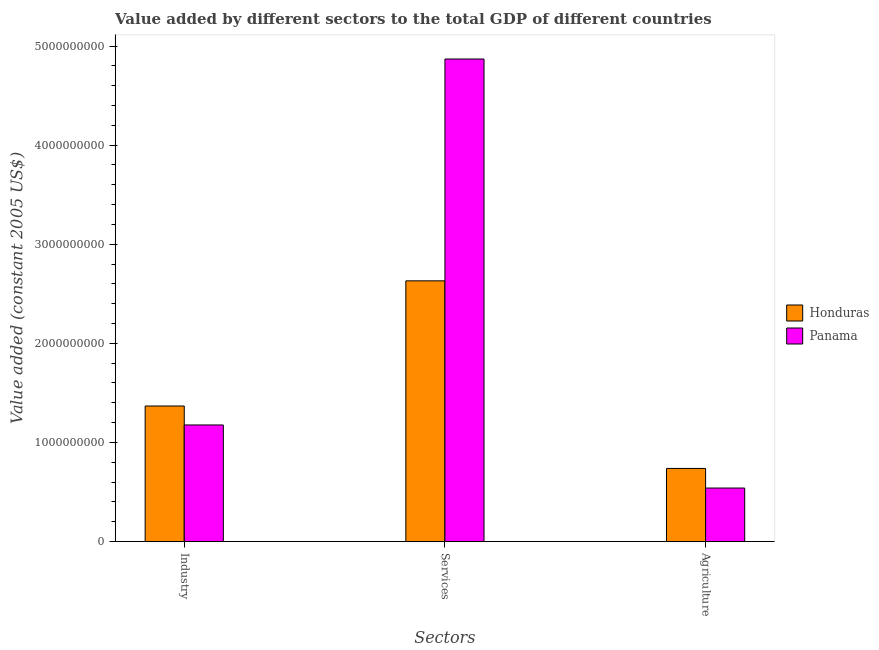How many different coloured bars are there?
Your answer should be compact. 2. How many groups of bars are there?
Your response must be concise. 3. Are the number of bars on each tick of the X-axis equal?
Your response must be concise. Yes. How many bars are there on the 3rd tick from the right?
Keep it short and to the point. 2. What is the label of the 1st group of bars from the left?
Provide a succinct answer. Industry. What is the value added by services in Panama?
Offer a very short reply. 4.87e+09. Across all countries, what is the maximum value added by industrial sector?
Provide a short and direct response. 1.37e+09. Across all countries, what is the minimum value added by agricultural sector?
Your answer should be very brief. 5.40e+08. In which country was the value added by agricultural sector maximum?
Offer a very short reply. Honduras. In which country was the value added by services minimum?
Provide a short and direct response. Honduras. What is the total value added by agricultural sector in the graph?
Ensure brevity in your answer.  1.28e+09. What is the difference between the value added by industrial sector in Honduras and that in Panama?
Your response must be concise. 1.91e+08. What is the difference between the value added by services in Honduras and the value added by agricultural sector in Panama?
Ensure brevity in your answer.  2.09e+09. What is the average value added by services per country?
Provide a short and direct response. 3.75e+09. What is the difference between the value added by services and value added by industrial sector in Honduras?
Offer a terse response. 1.26e+09. In how many countries, is the value added by agricultural sector greater than 200000000 US$?
Ensure brevity in your answer.  2. What is the ratio of the value added by industrial sector in Panama to that in Honduras?
Keep it short and to the point. 0.86. Is the value added by industrial sector in Honduras less than that in Panama?
Keep it short and to the point. No. Is the difference between the value added by industrial sector in Panama and Honduras greater than the difference between the value added by agricultural sector in Panama and Honduras?
Your response must be concise. Yes. What is the difference between the highest and the second highest value added by services?
Offer a terse response. 2.24e+09. What is the difference between the highest and the lowest value added by services?
Ensure brevity in your answer.  2.24e+09. Is the sum of the value added by industrial sector in Honduras and Panama greater than the maximum value added by agricultural sector across all countries?
Provide a short and direct response. Yes. What does the 2nd bar from the left in Agriculture represents?
Your response must be concise. Panama. What does the 2nd bar from the right in Services represents?
Provide a succinct answer. Honduras. How many bars are there?
Ensure brevity in your answer.  6. Are all the bars in the graph horizontal?
Your answer should be compact. No. How many countries are there in the graph?
Your response must be concise. 2. What is the difference between two consecutive major ticks on the Y-axis?
Your answer should be very brief. 1.00e+09. How are the legend labels stacked?
Make the answer very short. Vertical. What is the title of the graph?
Your answer should be compact. Value added by different sectors to the total GDP of different countries. Does "Morocco" appear as one of the legend labels in the graph?
Provide a succinct answer. No. What is the label or title of the X-axis?
Offer a terse response. Sectors. What is the label or title of the Y-axis?
Provide a succinct answer. Value added (constant 2005 US$). What is the Value added (constant 2005 US$) of Honduras in Industry?
Offer a terse response. 1.37e+09. What is the Value added (constant 2005 US$) in Panama in Industry?
Your answer should be very brief. 1.18e+09. What is the Value added (constant 2005 US$) in Honduras in Services?
Keep it short and to the point. 2.63e+09. What is the Value added (constant 2005 US$) in Panama in Services?
Provide a short and direct response. 4.87e+09. What is the Value added (constant 2005 US$) in Honduras in Agriculture?
Your answer should be very brief. 7.38e+08. What is the Value added (constant 2005 US$) of Panama in Agriculture?
Make the answer very short. 5.40e+08. Across all Sectors, what is the maximum Value added (constant 2005 US$) in Honduras?
Keep it short and to the point. 2.63e+09. Across all Sectors, what is the maximum Value added (constant 2005 US$) of Panama?
Provide a short and direct response. 4.87e+09. Across all Sectors, what is the minimum Value added (constant 2005 US$) of Honduras?
Offer a terse response. 7.38e+08. Across all Sectors, what is the minimum Value added (constant 2005 US$) in Panama?
Provide a succinct answer. 5.40e+08. What is the total Value added (constant 2005 US$) of Honduras in the graph?
Offer a very short reply. 4.74e+09. What is the total Value added (constant 2005 US$) of Panama in the graph?
Ensure brevity in your answer.  6.59e+09. What is the difference between the Value added (constant 2005 US$) in Honduras in Industry and that in Services?
Your answer should be compact. -1.26e+09. What is the difference between the Value added (constant 2005 US$) of Panama in Industry and that in Services?
Keep it short and to the point. -3.69e+09. What is the difference between the Value added (constant 2005 US$) in Honduras in Industry and that in Agriculture?
Give a very brief answer. 6.30e+08. What is the difference between the Value added (constant 2005 US$) of Panama in Industry and that in Agriculture?
Provide a succinct answer. 6.36e+08. What is the difference between the Value added (constant 2005 US$) of Honduras in Services and that in Agriculture?
Your response must be concise. 1.89e+09. What is the difference between the Value added (constant 2005 US$) in Panama in Services and that in Agriculture?
Make the answer very short. 4.33e+09. What is the difference between the Value added (constant 2005 US$) of Honduras in Industry and the Value added (constant 2005 US$) of Panama in Services?
Your answer should be very brief. -3.50e+09. What is the difference between the Value added (constant 2005 US$) in Honduras in Industry and the Value added (constant 2005 US$) in Panama in Agriculture?
Provide a succinct answer. 8.28e+08. What is the difference between the Value added (constant 2005 US$) in Honduras in Services and the Value added (constant 2005 US$) in Panama in Agriculture?
Your response must be concise. 2.09e+09. What is the average Value added (constant 2005 US$) of Honduras per Sectors?
Give a very brief answer. 1.58e+09. What is the average Value added (constant 2005 US$) in Panama per Sectors?
Ensure brevity in your answer.  2.20e+09. What is the difference between the Value added (constant 2005 US$) of Honduras and Value added (constant 2005 US$) of Panama in Industry?
Keep it short and to the point. 1.91e+08. What is the difference between the Value added (constant 2005 US$) of Honduras and Value added (constant 2005 US$) of Panama in Services?
Make the answer very short. -2.24e+09. What is the difference between the Value added (constant 2005 US$) in Honduras and Value added (constant 2005 US$) in Panama in Agriculture?
Offer a terse response. 1.98e+08. What is the ratio of the Value added (constant 2005 US$) in Honduras in Industry to that in Services?
Make the answer very short. 0.52. What is the ratio of the Value added (constant 2005 US$) in Panama in Industry to that in Services?
Offer a very short reply. 0.24. What is the ratio of the Value added (constant 2005 US$) of Honduras in Industry to that in Agriculture?
Ensure brevity in your answer.  1.85. What is the ratio of the Value added (constant 2005 US$) of Panama in Industry to that in Agriculture?
Offer a very short reply. 2.18. What is the ratio of the Value added (constant 2005 US$) in Honduras in Services to that in Agriculture?
Keep it short and to the point. 3.57. What is the ratio of the Value added (constant 2005 US$) of Panama in Services to that in Agriculture?
Make the answer very short. 9.02. What is the difference between the highest and the second highest Value added (constant 2005 US$) in Honduras?
Ensure brevity in your answer.  1.26e+09. What is the difference between the highest and the second highest Value added (constant 2005 US$) in Panama?
Your response must be concise. 3.69e+09. What is the difference between the highest and the lowest Value added (constant 2005 US$) in Honduras?
Provide a succinct answer. 1.89e+09. What is the difference between the highest and the lowest Value added (constant 2005 US$) of Panama?
Give a very brief answer. 4.33e+09. 